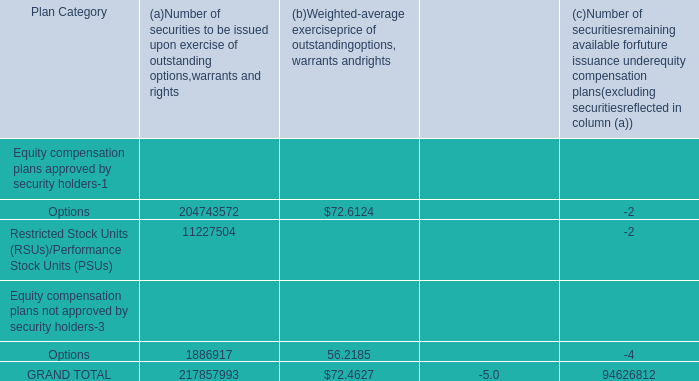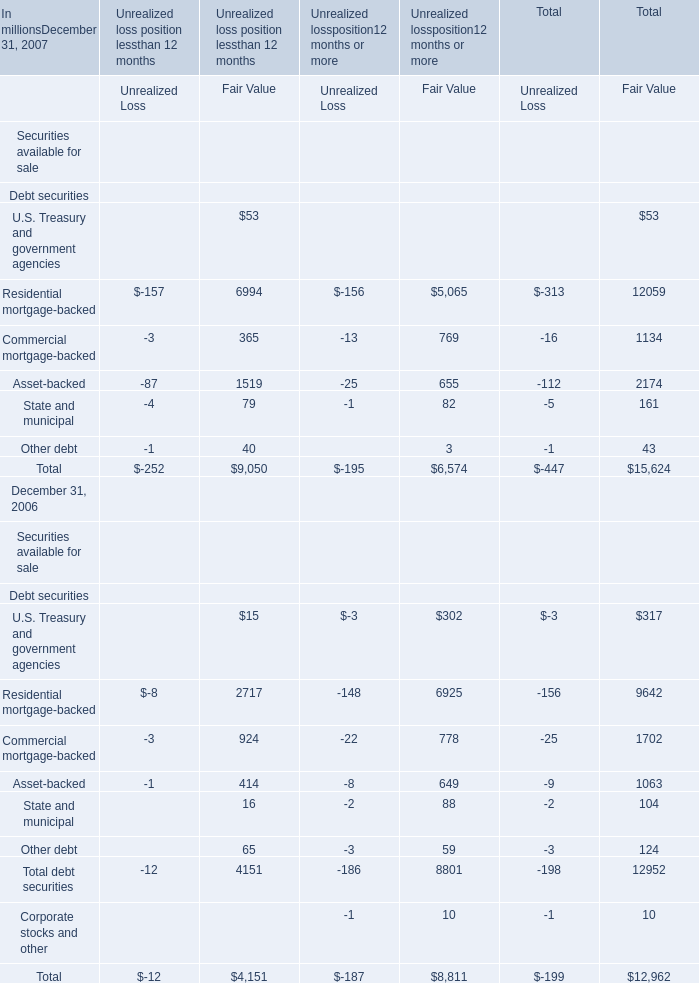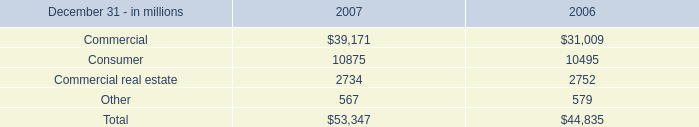What was the Fair Value for Total debt securities in terms of Unrealized loss position less than 12 months at December 31, 2006? (in million) 
Answer: 4151. 